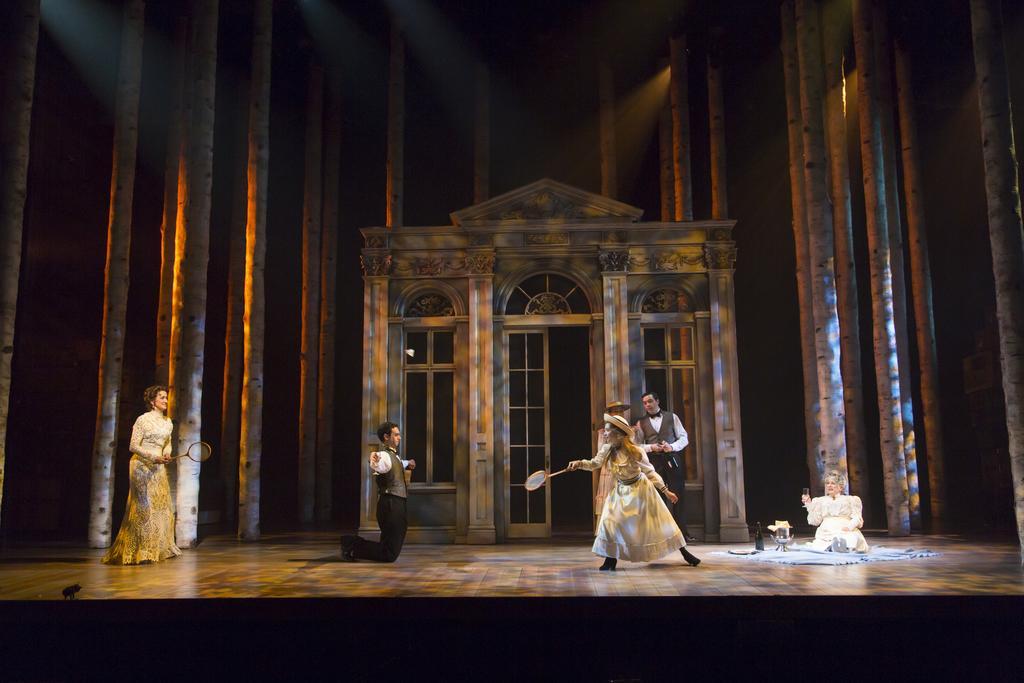Please provide a concise description of this image. In the center of the image we can see two ladies standing and holding rackets in their hands. In the background there are men. On the right we can see a lady sitting. In the background there is a door. 